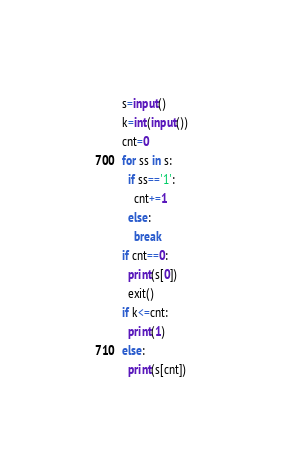Convert code to text. <code><loc_0><loc_0><loc_500><loc_500><_Python_>s=input()
k=int(input())
cnt=0
for ss in s:
  if ss=='1':
    cnt+=1
  else:
    break
if cnt==0:
  print(s[0])
  exit()
if k<=cnt:
  print(1)
else:
  print(s[cnt])</code> 